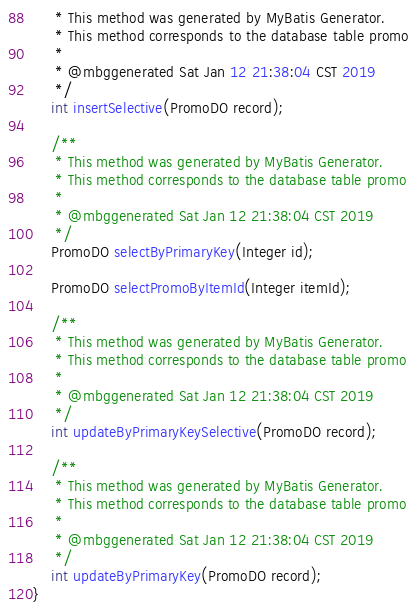Convert code to text. <code><loc_0><loc_0><loc_500><loc_500><_Java_>     * This method was generated by MyBatis Generator.
     * This method corresponds to the database table promo
     *
     * @mbggenerated Sat Jan 12 21:38:04 CST 2019
     */
    int insertSelective(PromoDO record);

    /**
     * This method was generated by MyBatis Generator.
     * This method corresponds to the database table promo
     *
     * @mbggenerated Sat Jan 12 21:38:04 CST 2019
     */
    PromoDO selectByPrimaryKey(Integer id);

    PromoDO selectPromoByItemId(Integer itemId);

    /**
     * This method was generated by MyBatis Generator.
     * This method corresponds to the database table promo
     *
     * @mbggenerated Sat Jan 12 21:38:04 CST 2019
     */
    int updateByPrimaryKeySelective(PromoDO record);

    /**
     * This method was generated by MyBatis Generator.
     * This method corresponds to the database table promo
     *
     * @mbggenerated Sat Jan 12 21:38:04 CST 2019
     */
    int updateByPrimaryKey(PromoDO record);
}</code> 